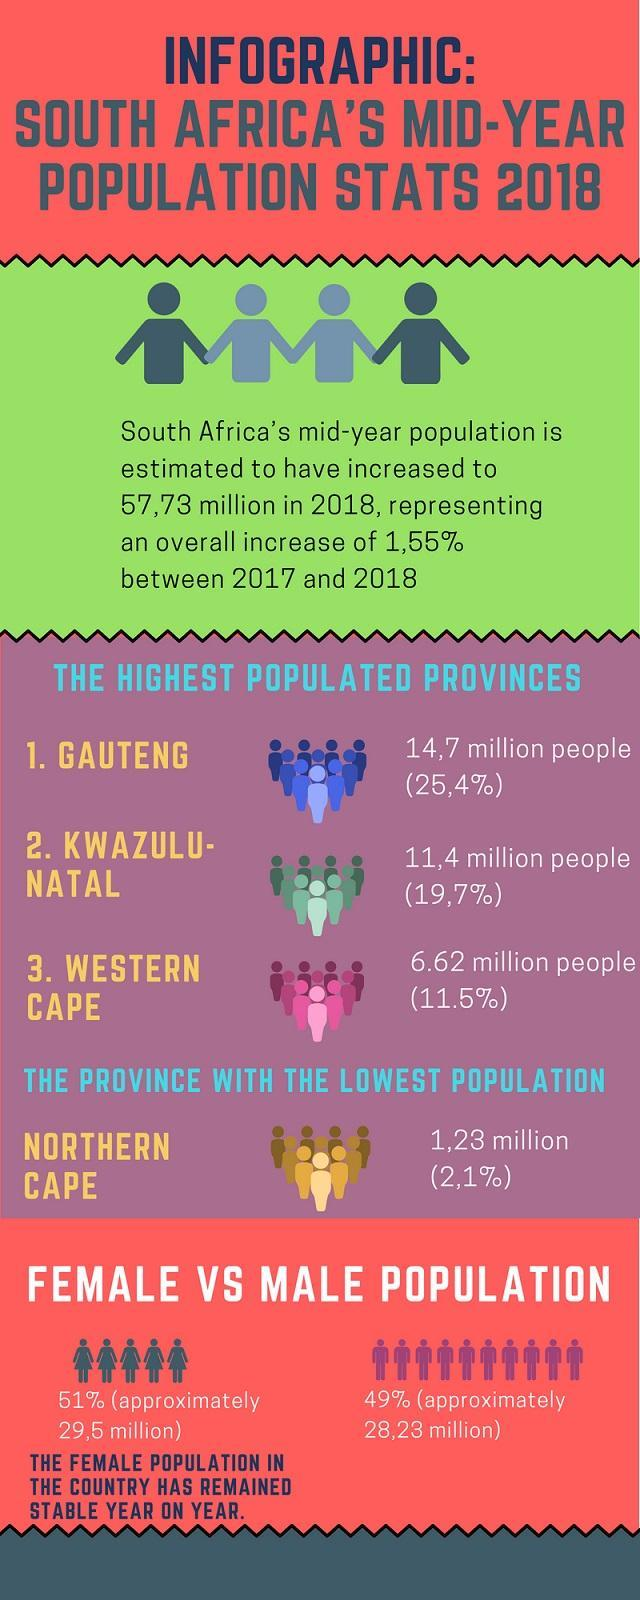How many provinces mentioned in this infographic?
Answer the question with a short phrase. 4 What is the percentage of Gauteng and Western Cape, taken together? 36.9% 